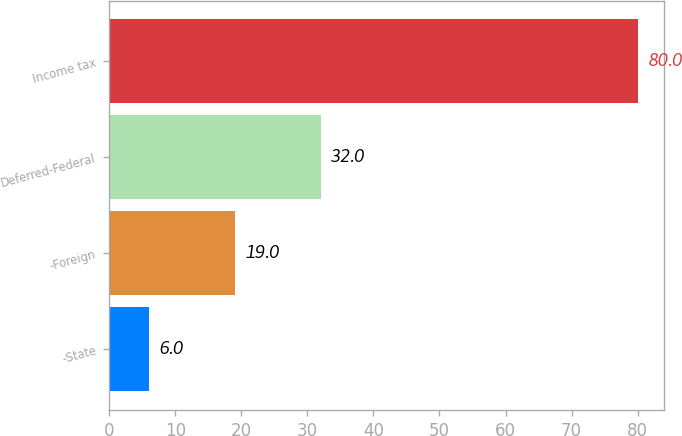Convert chart to OTSL. <chart><loc_0><loc_0><loc_500><loc_500><bar_chart><fcel>-State<fcel>-Foreign<fcel>Deferred-Federal<fcel>Income tax<nl><fcel>6<fcel>19<fcel>32<fcel>80<nl></chart> 